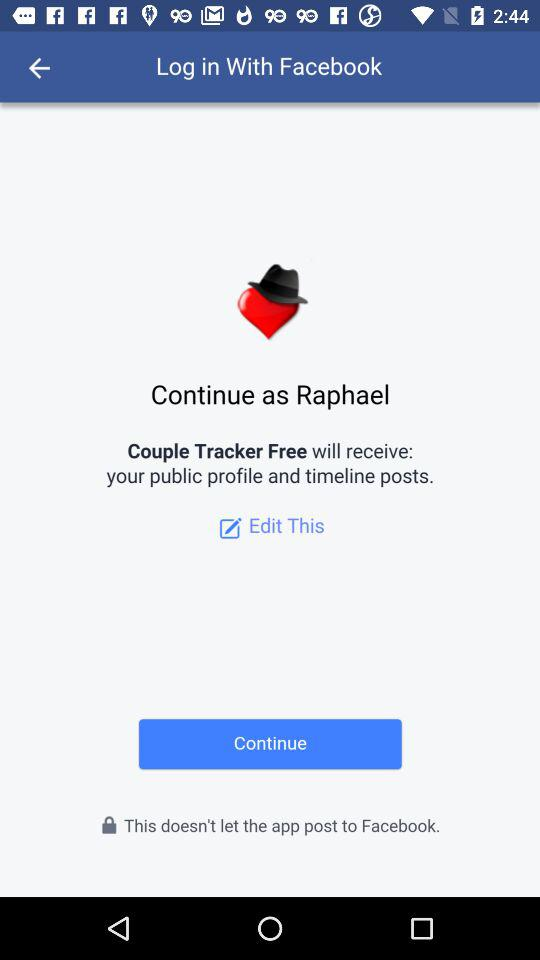Who will receive the public profile and timeline posts? The public profile and timeline posts will be received by "Couple Tracker Free". 